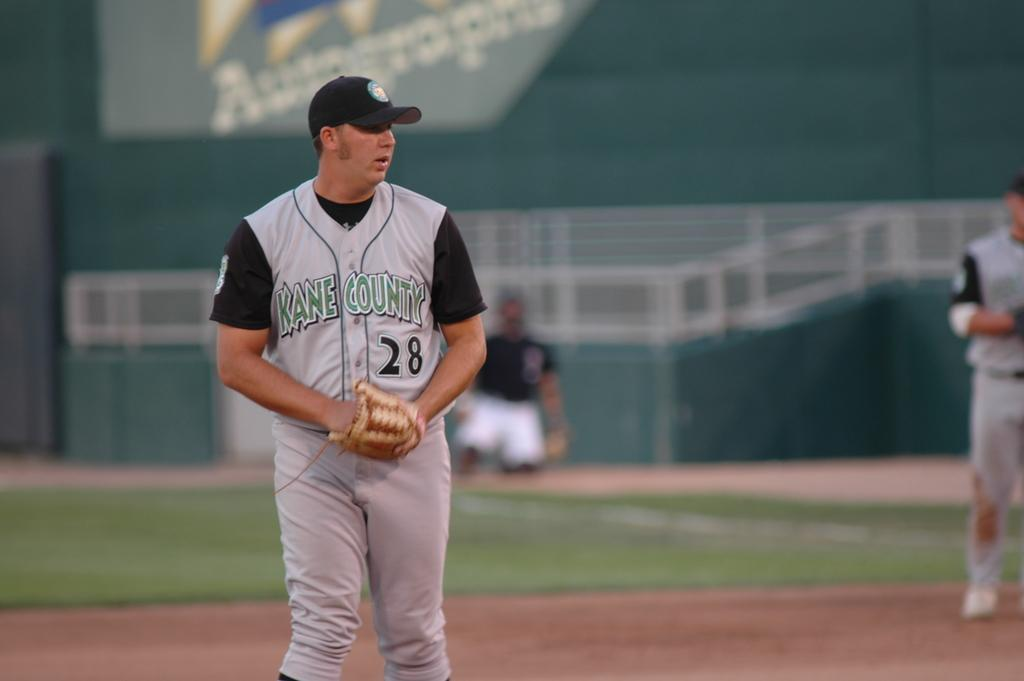<image>
Share a concise interpretation of the image provided. A pitcher from Kane County on a baseball field 